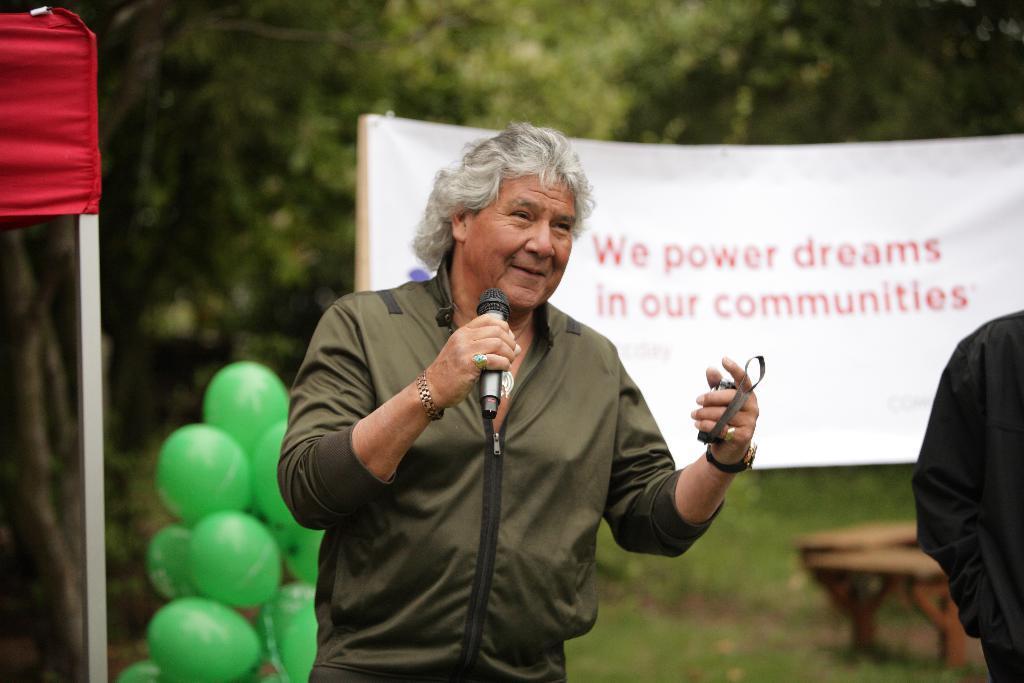In one or two sentences, can you explain what this image depicts? In this image we can see a man standing and holding a mic and a mobile in his hand, next to him there is another person. In the background there is a bench, board, trees, balloons, pole and a cloth. 